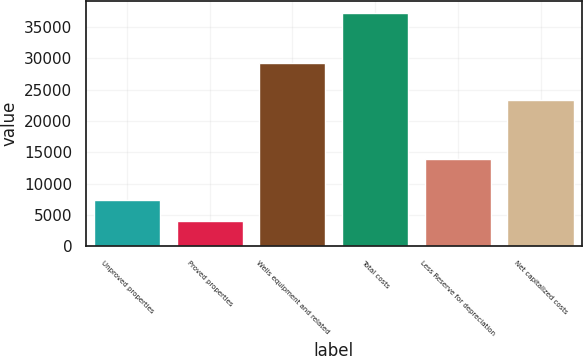<chart> <loc_0><loc_0><loc_500><loc_500><bar_chart><fcel>Unproved properties<fcel>Proved properties<fcel>Wells equipment and related<fcel>Total costs<fcel>Less Reserve for depreciation<fcel>Net capitalized costs<nl><fcel>7305.3<fcel>3975<fcel>29239<fcel>37278<fcel>13900<fcel>23378<nl></chart> 